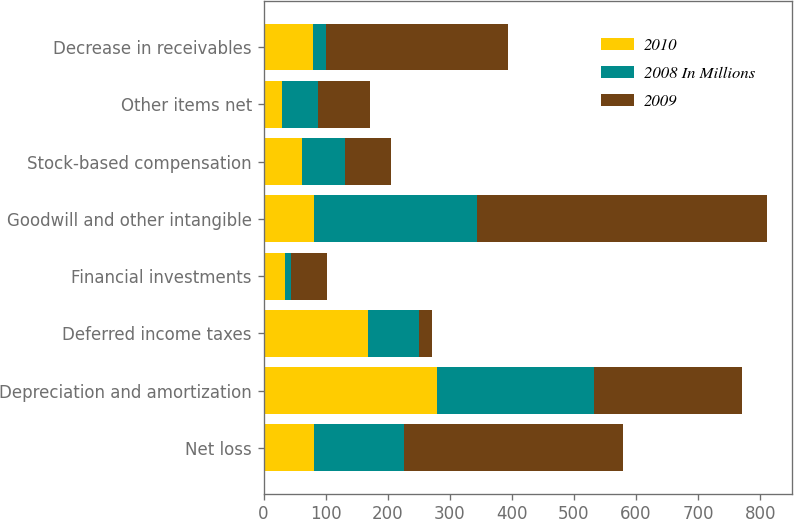Convert chart to OTSL. <chart><loc_0><loc_0><loc_500><loc_500><stacked_bar_chart><ecel><fcel>Net loss<fcel>Depreciation and amortization<fcel>Deferred income taxes<fcel>Financial investments<fcel>Goodwill and other intangible<fcel>Stock-based compensation<fcel>Other items net<fcel>Decrease in receivables<nl><fcel>2010<fcel>81.5<fcel>279<fcel>168<fcel>34<fcel>81.5<fcel>62<fcel>29<fcel>80<nl><fcel>2008 In Millions<fcel>145<fcel>254<fcel>83<fcel>10<fcel>262<fcel>69<fcel>58<fcel>20<nl><fcel>2009<fcel>352<fcel>238<fcel>20<fcel>58<fcel>467<fcel>74<fcel>84<fcel>294<nl></chart> 